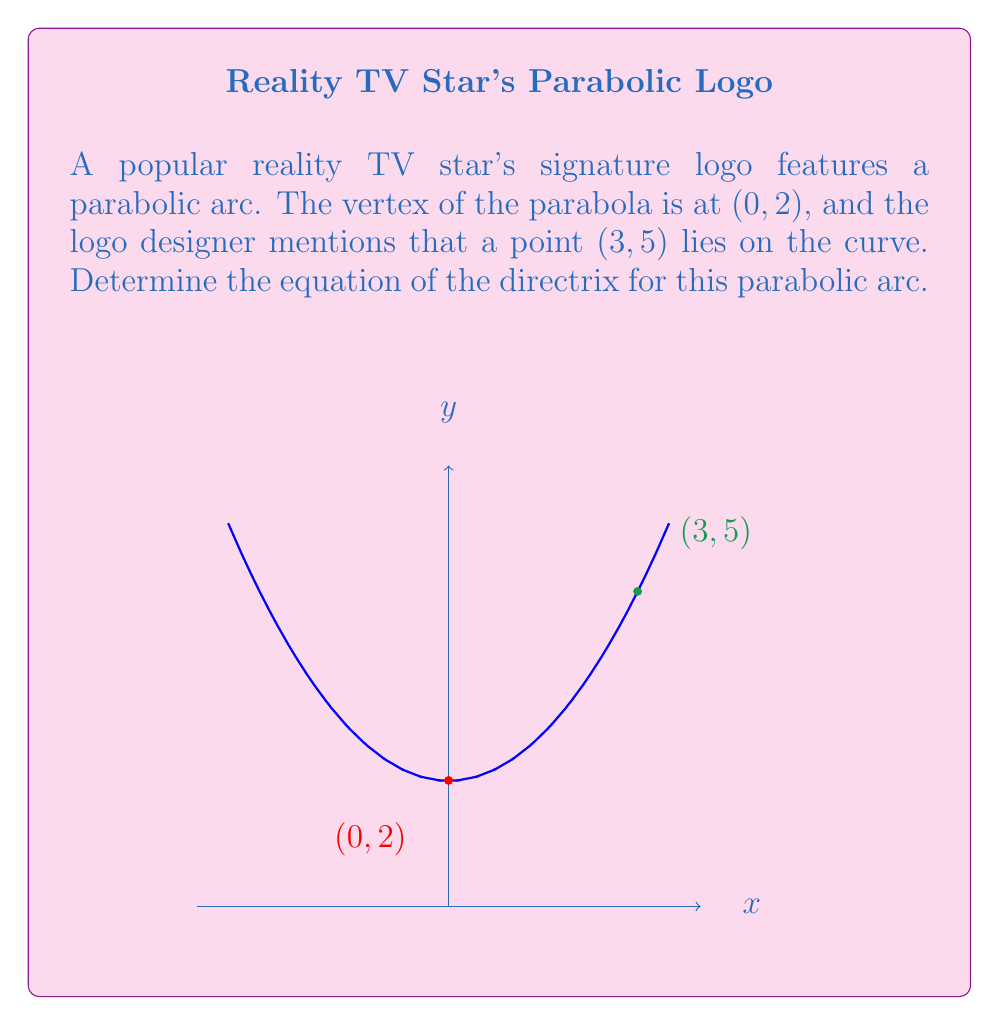Show me your answer to this math problem. Let's approach this step-by-step:

1) The general equation of a parabola with vertex (h, k) is:
   $$(y - k) = a(x - h)^2$$

2) We know the vertex is at (0, 2), so h = 0 and k = 2. Our equation becomes:
   $$(y - 2) = a(x - 0)^2 = ax^2$$

3) We can use the point (3, 5) to find the value of a:
   $$(5 - 2) = a(3)^2$$
   $$3 = 9a$$
   $$a = \frac{1}{3}$$

4) So, the equation of our parabola is:
   $$(y - 2) = \frac{1}{3}x^2$$

5) For a parabola in the form $y = ax^2 + bx + c$, the equation of the directrix is:
   $$y = k - \frac{1}{4a}$$
   where k is the y-coordinate of the vertex and a is the coefficient of $x^2$.

6) In our case, k = 2 and a = $\frac{1}{3}$. Let's substitute:
   $$y = 2 - \frac{1}{4(\frac{1}{3})} = 2 - \frac{3}{4} = 2 - 0.75 = 1.25$$

Therefore, the equation of the directrix is y = 1.25.
Answer: y = 1.25 